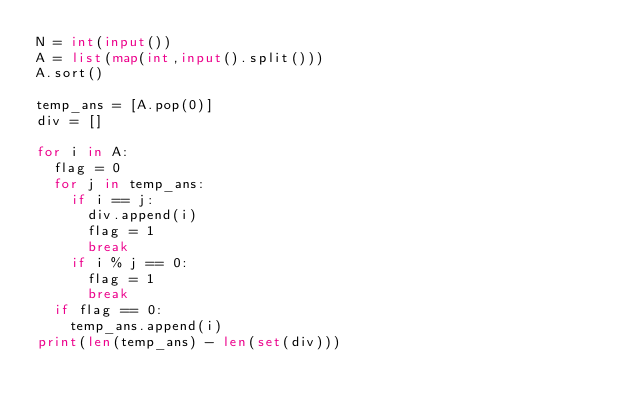<code> <loc_0><loc_0><loc_500><loc_500><_Python_>N = int(input())
A = list(map(int,input().split()))
A.sort()

temp_ans = [A.pop(0)]
div = []

for i in A:
  flag = 0
  for j in temp_ans:
    if i == j:
      div.append(i)
      flag = 1
      break
    if i % j == 0:
      flag = 1
      break
  if flag == 0:
    temp_ans.append(i)
print(len(temp_ans) - len(set(div)))
</code> 